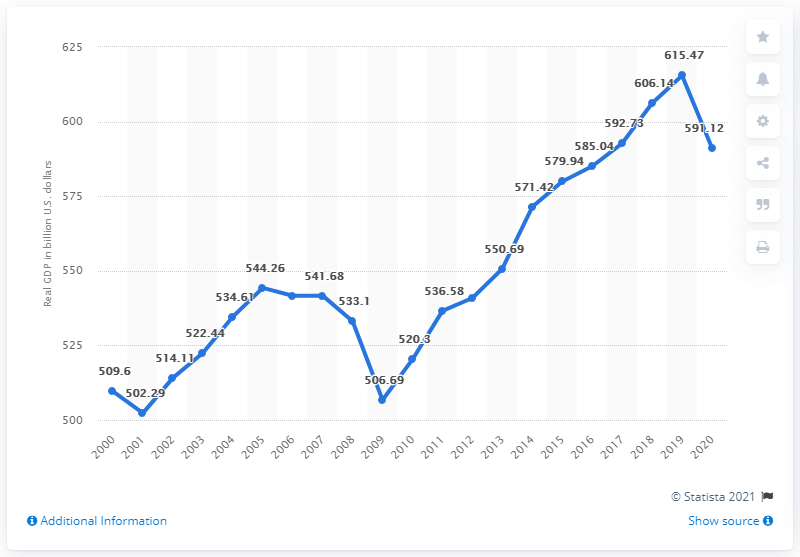Specify some key components in this picture. The maximum value of the chart is 615.47. The highest peak value and the lowest value in a dataset are 113.18, which represents the range of the data. The estimated Gross Domestic Product (GDP) of Ohio in 2020 was 615.47 billion dollars. In the year 2020, the Gross Domestic Product (GDP) of Ohio was 591.12. 